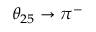<formula> <loc_0><loc_0><loc_500><loc_500>\theta _ { 2 5 } \to \pi ^ { - }</formula> 